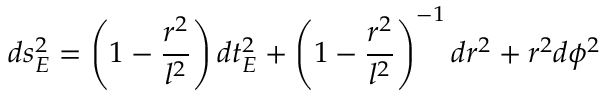<formula> <loc_0><loc_0><loc_500><loc_500>d s _ { E } ^ { 2 } = \left ( 1 - \frac { r ^ { 2 } } { l ^ { 2 } } \right ) d t _ { E } ^ { 2 } + \left ( 1 - \frac { r ^ { 2 } } { l ^ { 2 } } \right ) ^ { - 1 } d r ^ { 2 } + r ^ { 2 } d \phi ^ { 2 }</formula> 